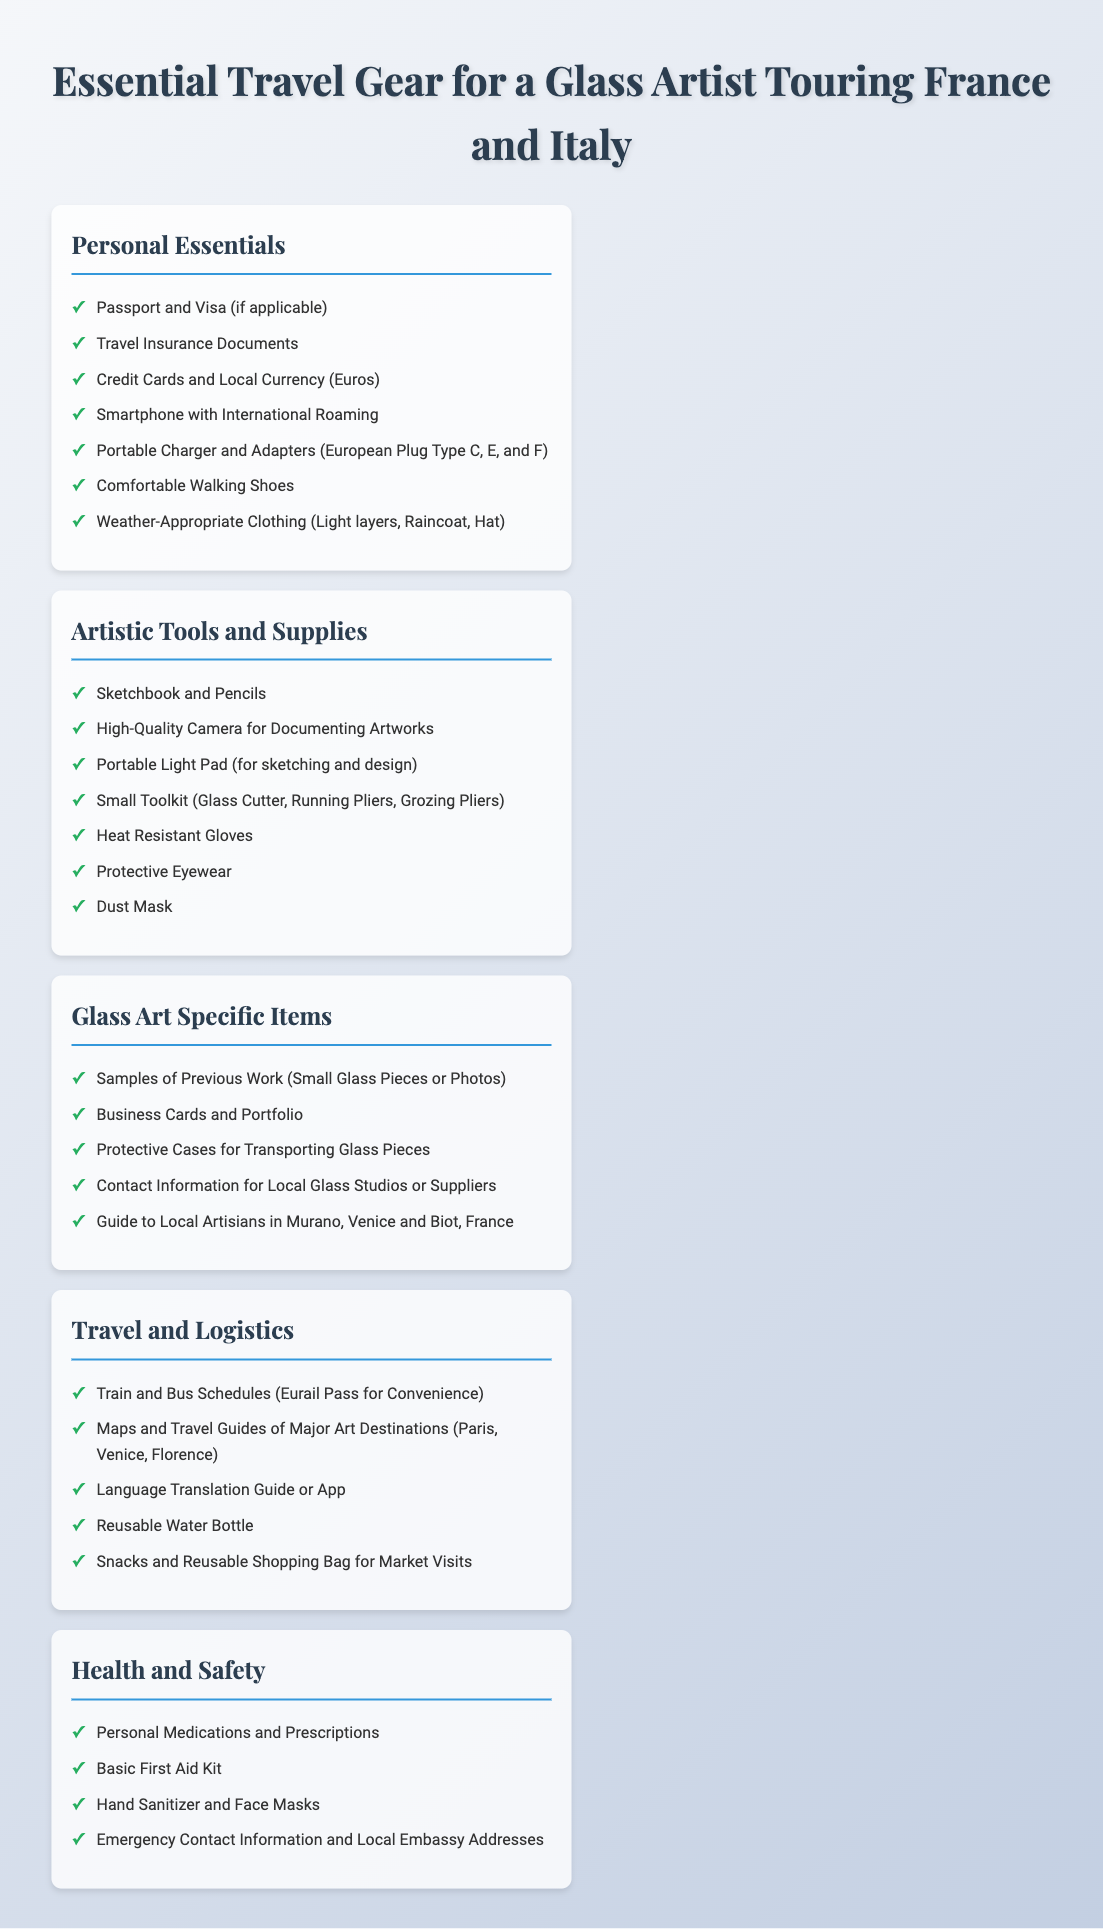What are the essential personal items for a glass artist? The personal items listed in the document include items such as passport, travel insurance documents, and comfortable walking shoes among others.
Answer: Passport and Visa (if applicable) How many sections are there in the packing list? The packing list is divided into five different sections covering essentials, tools, specific items, travel logistics, and health safety.
Answer: Five What type of personal document is mentioned under personal essentials? The document explicitly states the need for a passport and visa when traveling.
Answer: Passport and Visa (if applicable) What supplies are necessary for documenting artworks? The packing list specifies that a high-quality camera is required to document artworks.
Answer: High-Quality Camera for Documenting Artworks Which specific protective item is recommended for handling glass? The packing list emphasizes that heat-resistant gloves are necessary for protection while working with glass.
Answer: Heat Resistant Gloves What is recommended for sketching and design purposes? The document mentions that a portable light pad is important for assisting in sketching and design tasks.
Answer: Portable Light Pad Which type of clothing is suggested for the trip? The list of personal essentials points out the need for weather-appropriate clothing, including light layers and a raincoat.
Answer: Weather-Appropriate Clothing (Light layers, Raincoat, Hat) What is one specific health item included in the packing list? The health and safety section recommends carrying personal medications as a crucial health item.
Answer: Personal Medications and Prescriptions What should a glass artist have for networking? The packing list states that business cards and a portfolio should be included for networking purposes.
Answer: Business Cards and Portfolio 